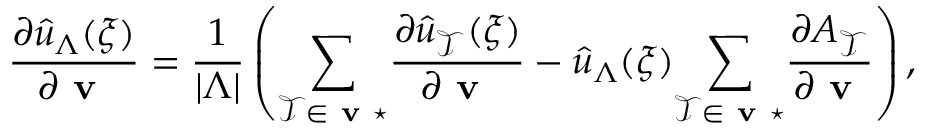<formula> <loc_0><loc_0><loc_500><loc_500>\frac { \partial \hat { u } _ { \Lambda } ( \xi ) } { \partial v } = \frac { 1 } { | \Lambda | } \left ( \underset { \mathcal { T } \in v ^ { * } } { \sum } \frac { \partial \hat { u } _ { \mathcal { T } } ( \xi ) } { \partial v } - \hat { u } _ { \Lambda } ( \xi ) \underset { \mathcal { T } \in v ^ { * } } { \sum } \frac { \partial A _ { \mathcal { T } } } { \partial v } \right ) ,</formula> 